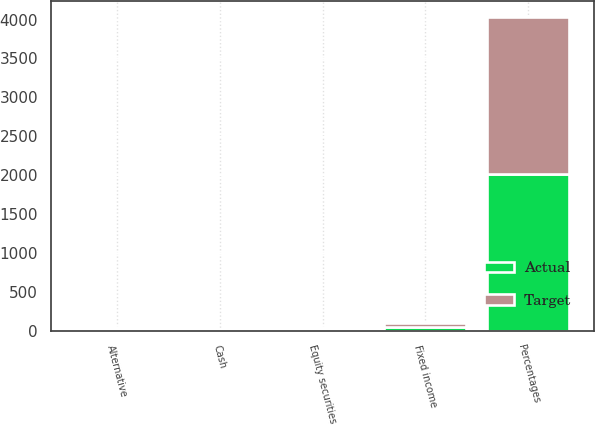<chart> <loc_0><loc_0><loc_500><loc_500><stacked_bar_chart><ecel><fcel>Percentages<fcel>Equity securities<fcel>Fixed income<fcel>Alternative<fcel>Cash<nl><fcel>Target<fcel>2017<fcel>22<fcel>53<fcel>22<fcel>3<nl><fcel>Actual<fcel>2017<fcel>24<fcel>51<fcel>23<fcel>2<nl></chart> 